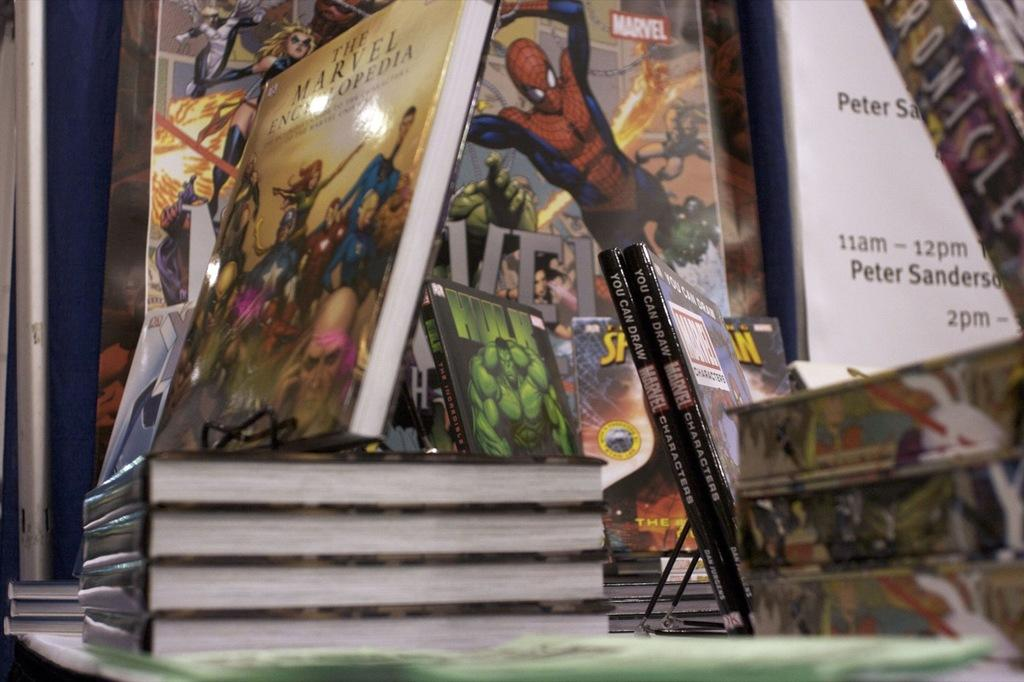<image>
Relay a brief, clear account of the picture shown. A display of books include titles like the Marvel Encyclopedia and You Can Draw Marvel. 